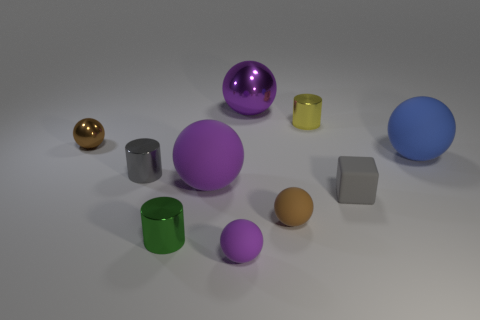How many balls are both in front of the tiny yellow metal cylinder and right of the tiny purple matte thing?
Your response must be concise. 2. Is there anything else that is the same shape as the gray rubber thing?
Offer a terse response. No. What number of other things are the same size as the brown matte ball?
Keep it short and to the point. 6. Does the metallic object in front of the tiny brown rubber sphere have the same size as the purple ball that is behind the tiny yellow object?
Offer a terse response. No. How many things are either small shiny balls or rubber balls that are on the left side of the large blue ball?
Your response must be concise. 4. There is a rubber ball that is left of the small purple thing; what size is it?
Your response must be concise. Large. Is the number of yellow metal cylinders to the left of the gray matte thing less than the number of tiny shiny objects that are behind the green shiny cylinder?
Provide a short and direct response. Yes. What material is the object that is behind the brown metal object and in front of the large metal sphere?
Provide a short and direct response. Metal. What is the shape of the brown rubber thing right of the big matte sphere that is in front of the large blue matte ball?
Give a very brief answer. Sphere. What number of red objects are either small spheres or small cubes?
Your answer should be compact. 0. 